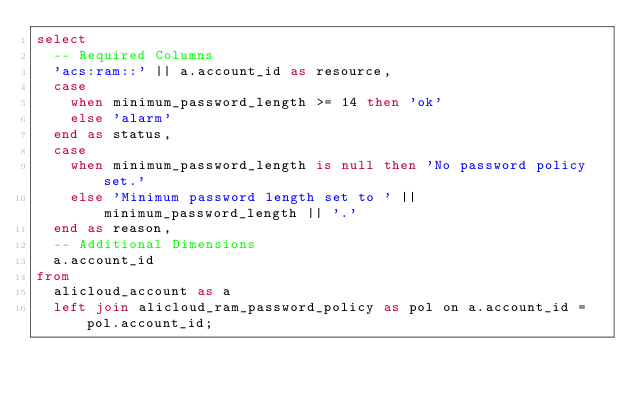Convert code to text. <code><loc_0><loc_0><loc_500><loc_500><_SQL_>select
  -- Required Columns
  'acs:ram::' || a.account_id as resource,
  case
    when minimum_password_length >= 14 then 'ok'
    else 'alarm'
  end as status,
  case
    when minimum_password_length is null then 'No password policy set.'
    else 'Minimum password length set to ' || minimum_password_length || '.'
  end as reason,
  -- Additional Dimensions
  a.account_id
from
  alicloud_account as a
  left join alicloud_ram_password_policy as pol on a.account_id = pol.account_id;</code> 